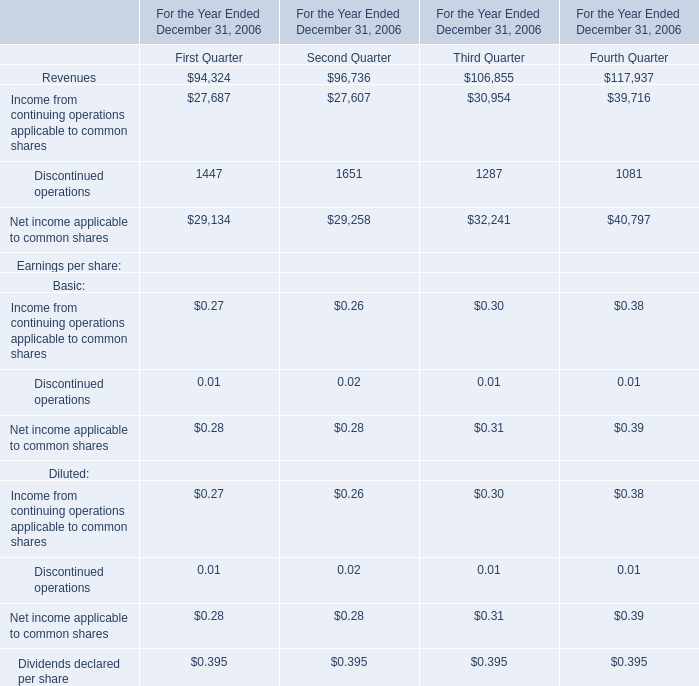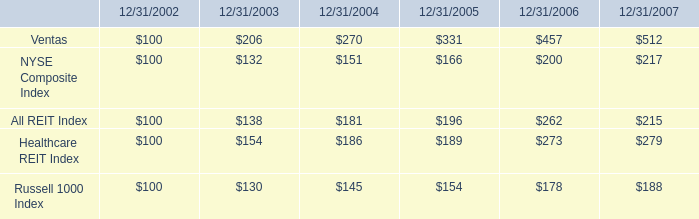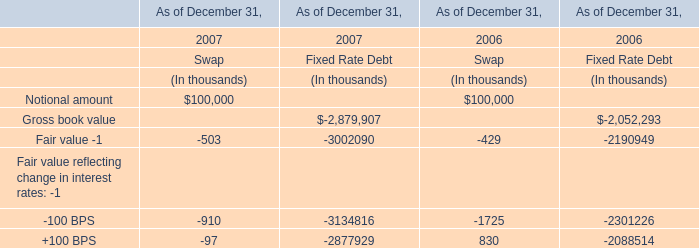In the section with lowest amount of Revenues, what's the increasing rate ofDiscontinued operations ? 
Computations: ((1447 - 1651) / 1447)
Answer: -0.14098. 